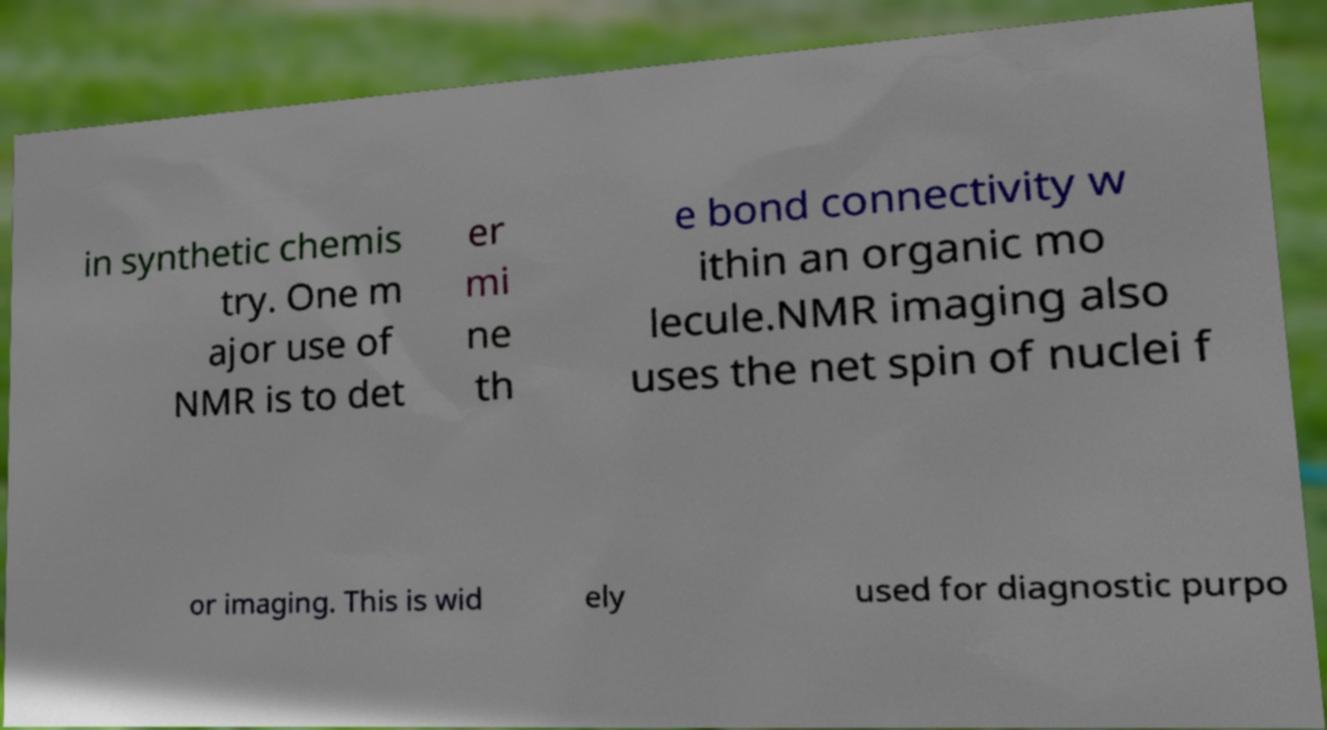Could you extract and type out the text from this image? in synthetic chemis try. One m ajor use of NMR is to det er mi ne th e bond connectivity w ithin an organic mo lecule.NMR imaging also uses the net spin of nuclei f or imaging. This is wid ely used for diagnostic purpo 